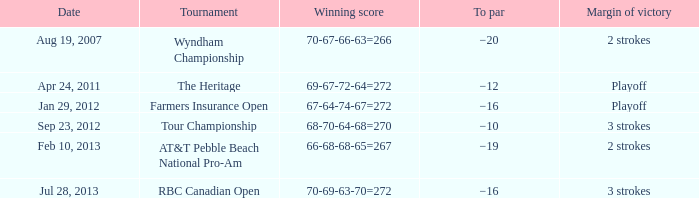What is the par for the contest with a winning score of 69-67-72-64=272? −12. 